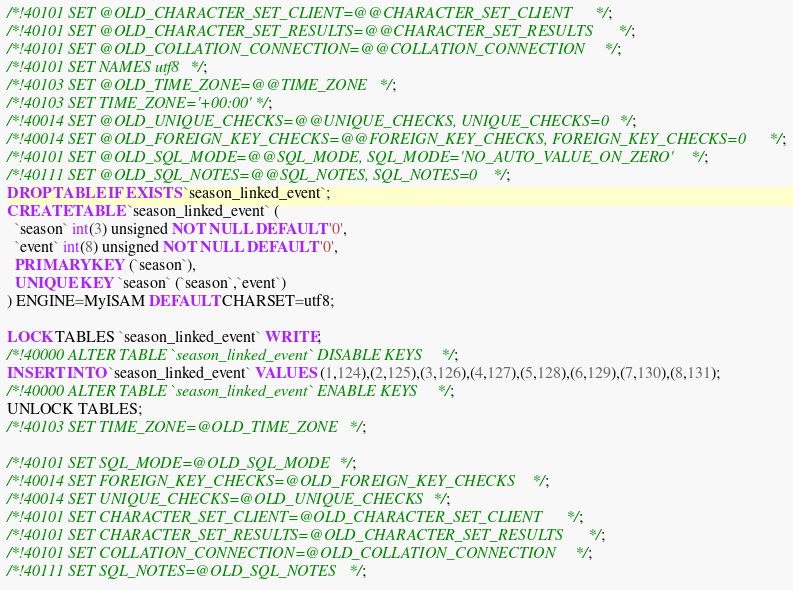<code> <loc_0><loc_0><loc_500><loc_500><_SQL_>
/*!40101 SET @OLD_CHARACTER_SET_CLIENT=@@CHARACTER_SET_CLIENT */;
/*!40101 SET @OLD_CHARACTER_SET_RESULTS=@@CHARACTER_SET_RESULTS */;
/*!40101 SET @OLD_COLLATION_CONNECTION=@@COLLATION_CONNECTION */;
/*!40101 SET NAMES utf8 */;
/*!40103 SET @OLD_TIME_ZONE=@@TIME_ZONE */;
/*!40103 SET TIME_ZONE='+00:00' */;
/*!40014 SET @OLD_UNIQUE_CHECKS=@@UNIQUE_CHECKS, UNIQUE_CHECKS=0 */;
/*!40014 SET @OLD_FOREIGN_KEY_CHECKS=@@FOREIGN_KEY_CHECKS, FOREIGN_KEY_CHECKS=0 */;
/*!40101 SET @OLD_SQL_MODE=@@SQL_MODE, SQL_MODE='NO_AUTO_VALUE_ON_ZERO' */;
/*!40111 SET @OLD_SQL_NOTES=@@SQL_NOTES, SQL_NOTES=0 */;
DROP TABLE IF EXISTS `season_linked_event`;
CREATE TABLE `season_linked_event` (
  `season` int(3) unsigned NOT NULL DEFAULT '0',
  `event` int(8) unsigned NOT NULL DEFAULT '0',
  PRIMARY KEY (`season`),
  UNIQUE KEY `season` (`season`,`event`)
) ENGINE=MyISAM DEFAULT CHARSET=utf8;

LOCK TABLES `season_linked_event` WRITE;
/*!40000 ALTER TABLE `season_linked_event` DISABLE KEYS */;
INSERT INTO `season_linked_event` VALUES (1,124),(2,125),(3,126),(4,127),(5,128),(6,129),(7,130),(8,131);
/*!40000 ALTER TABLE `season_linked_event` ENABLE KEYS */;
UNLOCK TABLES;
/*!40103 SET TIME_ZONE=@OLD_TIME_ZONE */;

/*!40101 SET SQL_MODE=@OLD_SQL_MODE */;
/*!40014 SET FOREIGN_KEY_CHECKS=@OLD_FOREIGN_KEY_CHECKS */;
/*!40014 SET UNIQUE_CHECKS=@OLD_UNIQUE_CHECKS */;
/*!40101 SET CHARACTER_SET_CLIENT=@OLD_CHARACTER_SET_CLIENT */;
/*!40101 SET CHARACTER_SET_RESULTS=@OLD_CHARACTER_SET_RESULTS */;
/*!40101 SET COLLATION_CONNECTION=@OLD_COLLATION_CONNECTION */;
/*!40111 SET SQL_NOTES=@OLD_SQL_NOTES */;

</code> 